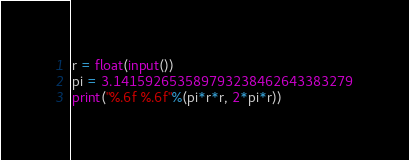<code> <loc_0><loc_0><loc_500><loc_500><_Python_>r = float(input())
pi = 3.141592653589793238462643383279
print("%.6f %.6f"%(pi*r*r, 2*pi*r))
</code> 